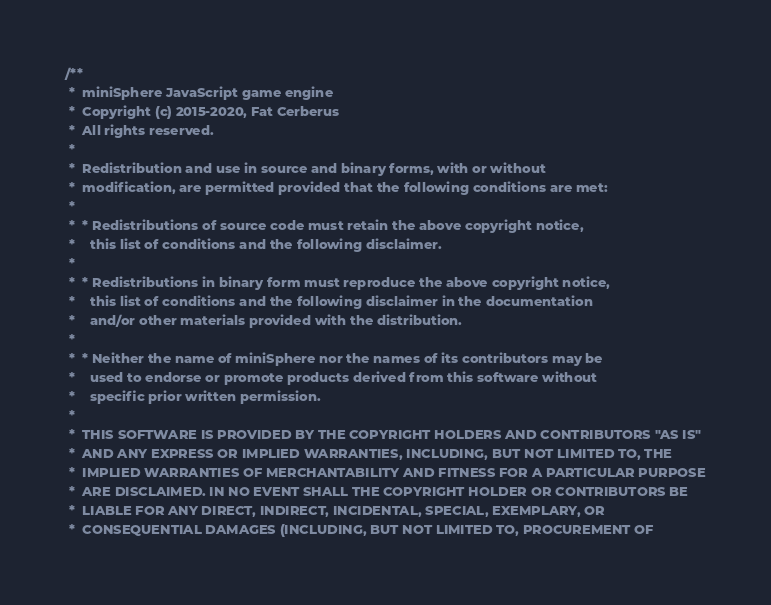<code> <loc_0><loc_0><loc_500><loc_500><_C_>/**
 *  miniSphere JavaScript game engine
 *  Copyright (c) 2015-2020, Fat Cerberus
 *  All rights reserved.
 *
 *  Redistribution and use in source and binary forms, with or without
 *  modification, are permitted provided that the following conditions are met:
 *
 *  * Redistributions of source code must retain the above copyright notice,
 *    this list of conditions and the following disclaimer.
 *
 *  * Redistributions in binary form must reproduce the above copyright notice,
 *    this list of conditions and the following disclaimer in the documentation
 *    and/or other materials provided with the distribution.
 *
 *  * Neither the name of miniSphere nor the names of its contributors may be
 *    used to endorse or promote products derived from this software without
 *    specific prior written permission.
 *
 *  THIS SOFTWARE IS PROVIDED BY THE COPYRIGHT HOLDERS AND CONTRIBUTORS "AS IS"
 *  AND ANY EXPRESS OR IMPLIED WARRANTIES, INCLUDING, BUT NOT LIMITED TO, THE
 *  IMPLIED WARRANTIES OF MERCHANTABILITY AND FITNESS FOR A PARTICULAR PURPOSE
 *  ARE DISCLAIMED. IN NO EVENT SHALL THE COPYRIGHT HOLDER OR CONTRIBUTORS BE
 *  LIABLE FOR ANY DIRECT, INDIRECT, INCIDENTAL, SPECIAL, EXEMPLARY, OR
 *  CONSEQUENTIAL DAMAGES (INCLUDING, BUT NOT LIMITED TO, PROCUREMENT OF</code> 